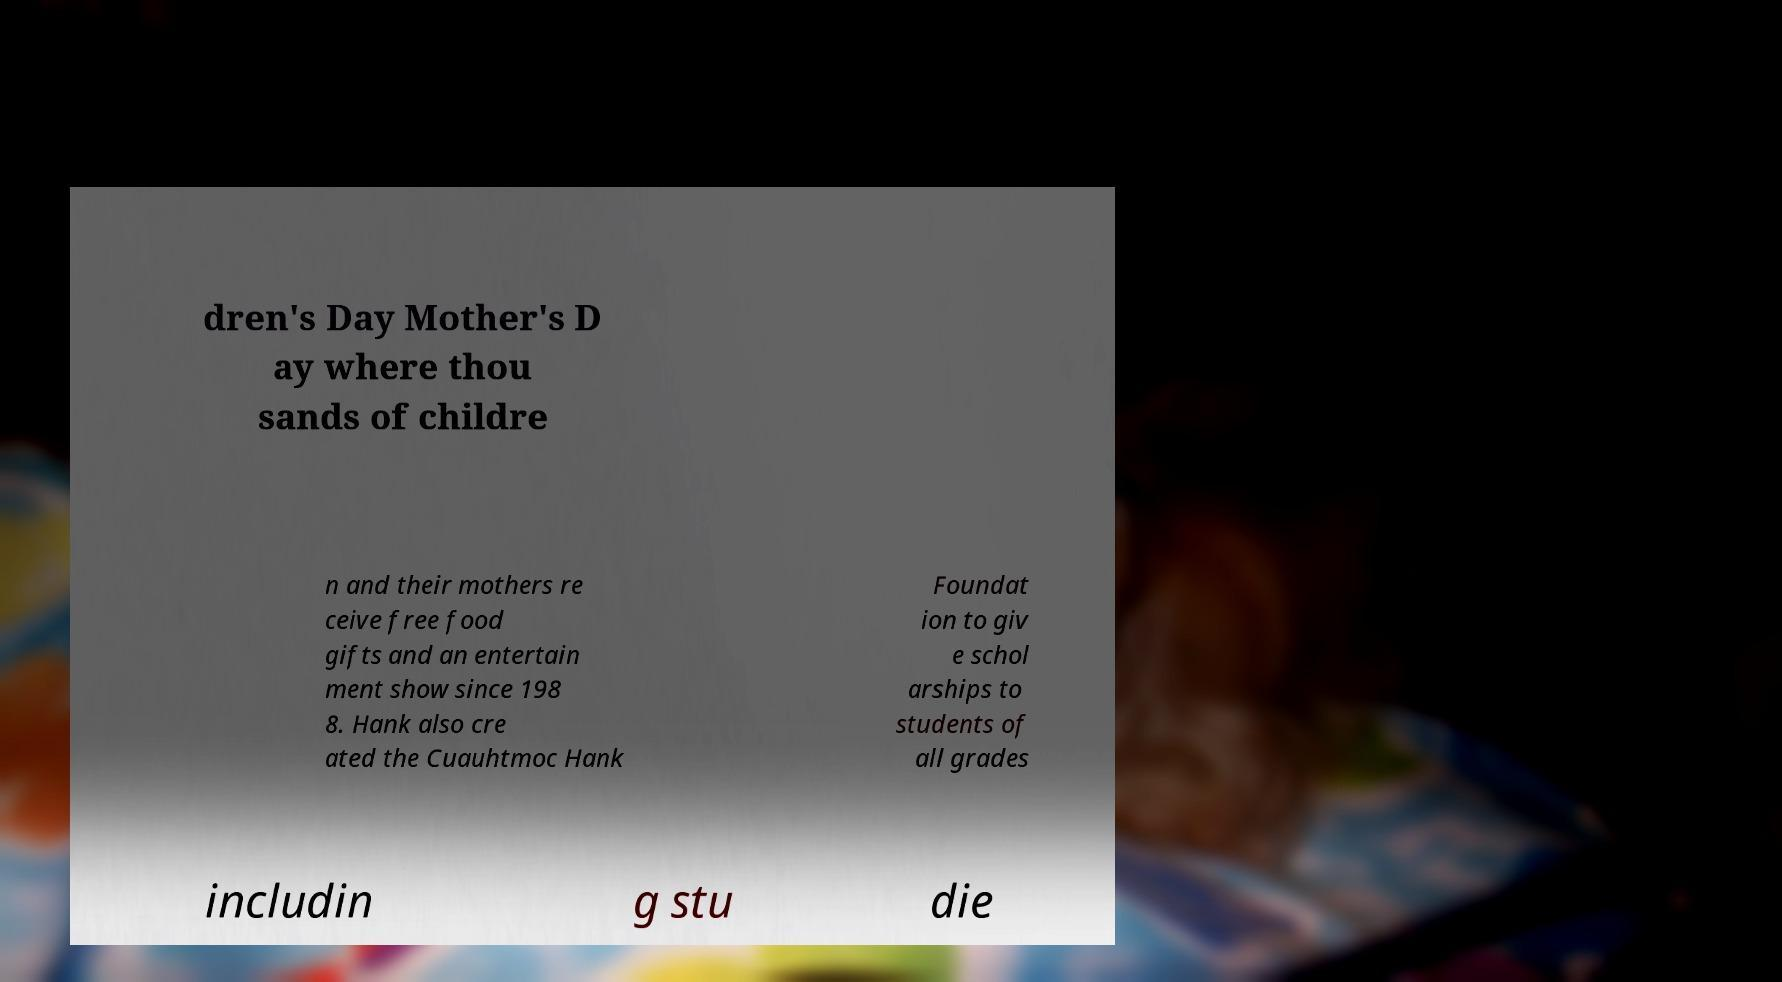Please identify and transcribe the text found in this image. dren's Day Mother's D ay where thou sands of childre n and their mothers re ceive free food gifts and an entertain ment show since 198 8. Hank also cre ated the Cuauhtmoc Hank Foundat ion to giv e schol arships to students of all grades includin g stu die 